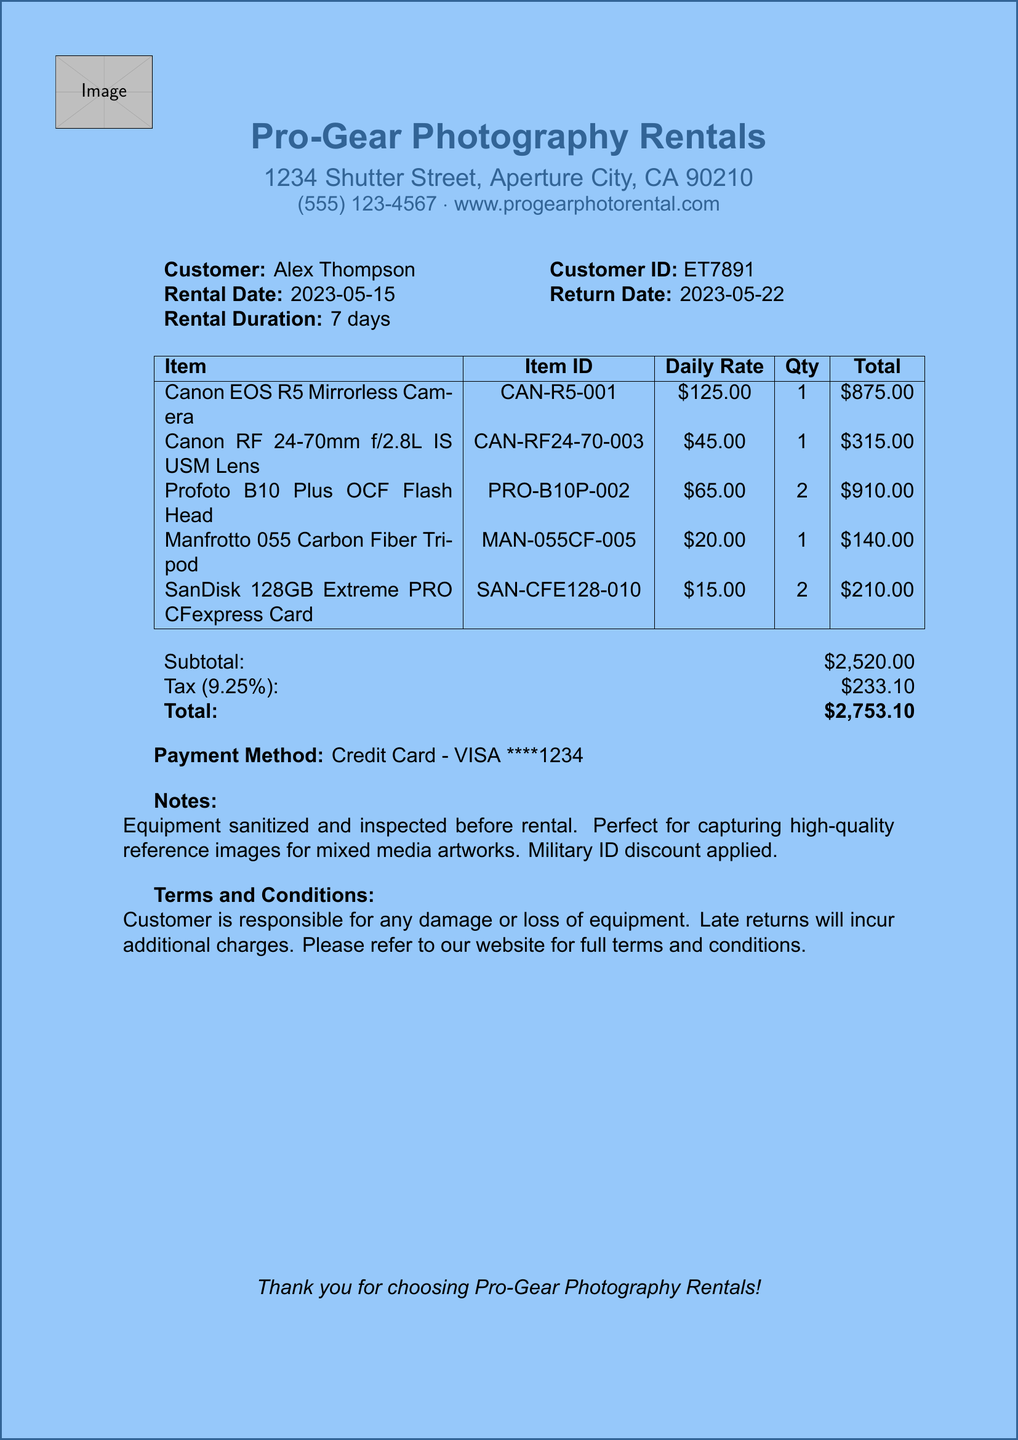What is the business name? The business name is displayed prominently at the top of the document.
Answer: Pro-Gear Photography Rentals What is the total amount due? The total amount is calculated at the bottom of the document after adding the subtotal and tax.
Answer: $2,753.10 What is the rental duration? The rental duration is mentioned in the customer section of the document.
Answer: 7 days Who is the customer? The document specifies the name of the customer for the rental.
Answer: Alex Thompson What is the phone number of the business? The phone number is listed right under the business name.
Answer: (555) 123-4567 What item has the highest daily rate? The items are listed with their daily rates, and the one with the highest rate must be identified.
Answer: Canon EOS R5 Mirrorless Camera How many SanDisk cards were rented? The quantity of each item rented is visible in the itemized list.
Answer: 2 What payment method was used? The payment method is stated near the end of the document.
Answer: Credit Card - VISA ****1234 What is the tax rate applied? The tax rate is indicated next to the tax amount in the financial summary section.
Answer: 9.25% 